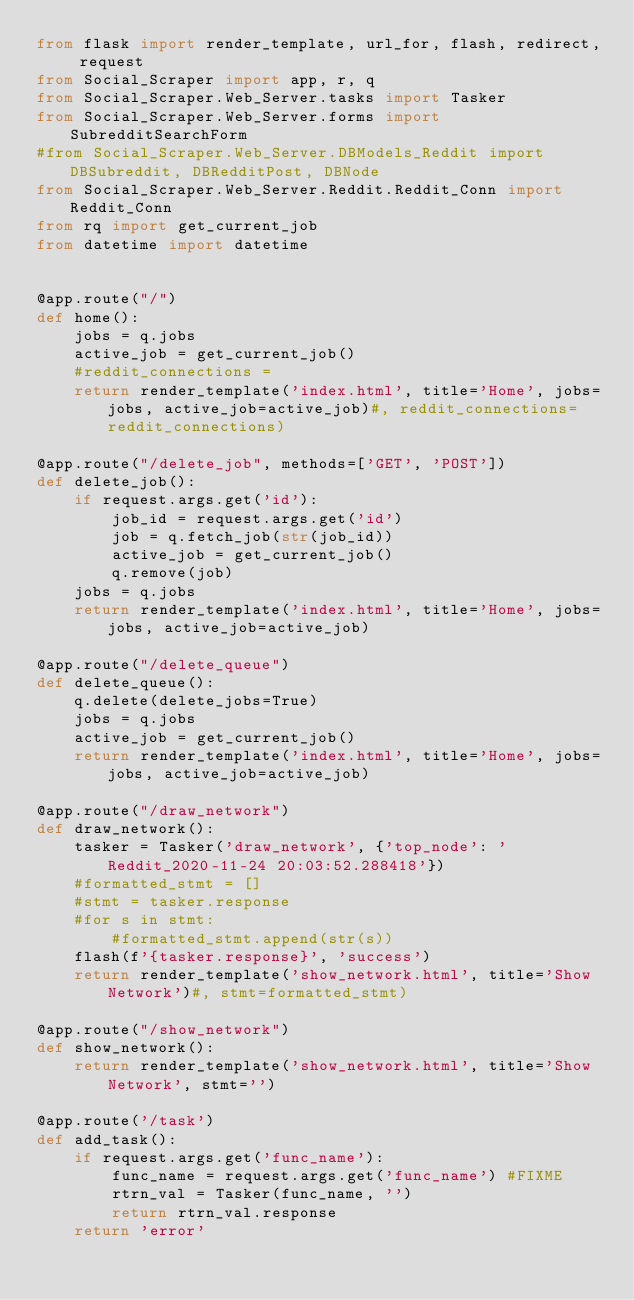<code> <loc_0><loc_0><loc_500><loc_500><_Python_>from flask import render_template, url_for, flash, redirect, request
from Social_Scraper import app, r, q
from Social_Scraper.Web_Server.tasks import Tasker
from Social_Scraper.Web_Server.forms import SubredditSearchForm
#from Social_Scraper.Web_Server.DBModels_Reddit import DBSubreddit, DBRedditPost, DBNode
from Social_Scraper.Web_Server.Reddit.Reddit_Conn import Reddit_Conn
from rq import get_current_job
from datetime import datetime


@app.route("/")
def home():
    jobs = q.jobs
    active_job = get_current_job()
    #reddit_connections =
    return render_template('index.html', title='Home', jobs=jobs, active_job=active_job)#, reddit_connections=reddit_connections)

@app.route("/delete_job", methods=['GET', 'POST'])
def delete_job():
    if request.args.get('id'):
        job_id = request.args.get('id')
        job = q.fetch_job(str(job_id))
        active_job = get_current_job()
        q.remove(job)
    jobs = q.jobs
    return render_template('index.html', title='Home', jobs=jobs, active_job=active_job)

@app.route("/delete_queue")
def delete_queue():
    q.delete(delete_jobs=True)
    jobs = q.jobs
    active_job = get_current_job()
    return render_template('index.html', title='Home', jobs=jobs, active_job=active_job)

@app.route("/draw_network")
def draw_network():
    tasker = Tasker('draw_network', {'top_node': 'Reddit_2020-11-24 20:03:52.288418'})
    #formatted_stmt = []
    #stmt = tasker.response
    #for s in stmt:
        #formatted_stmt.append(str(s))
    flash(f'{tasker.response}', 'success')
    return render_template('show_network.html', title='Show Network')#, stmt=formatted_stmt)

@app.route("/show_network")
def show_network():
    return render_template('show_network.html', title='Show Network', stmt='')

@app.route('/task')
def add_task():
    if request.args.get('func_name'):
        func_name = request.args.get('func_name') #FIXME
        rtrn_val = Tasker(func_name, '')
        return rtrn_val.response
    return 'error'
</code> 